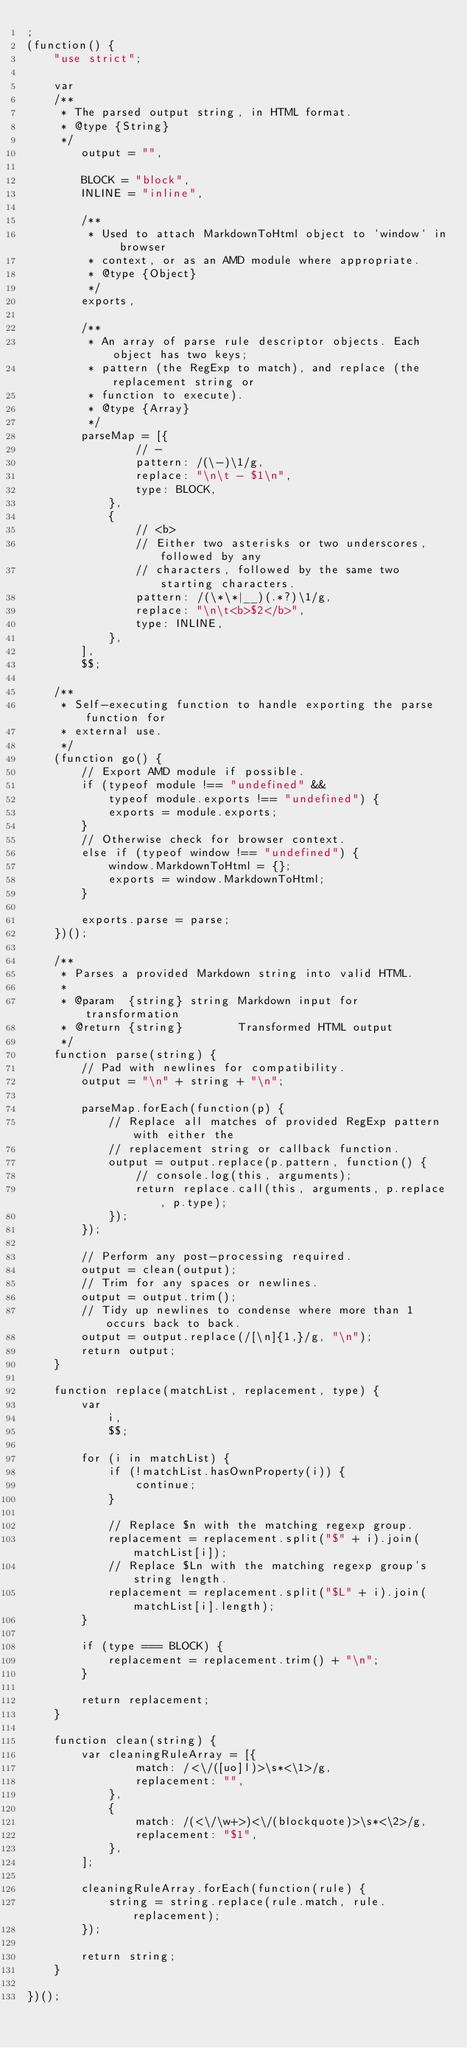Convert code to text. <code><loc_0><loc_0><loc_500><loc_500><_JavaScript_>;
(function() {
    "use strict";

    var
    /**
     * The parsed output string, in HTML format.
     * @type {String}
     */
        output = "",

        BLOCK = "block",
        INLINE = "inline",

        /**
         * Used to attach MarkdownToHtml object to `window` in browser
         * context, or as an AMD module where appropriate.
         * @type {Object}
         */
        exports,

        /**
         * An array of parse rule descriptor objects. Each object has two keys;
         * pattern (the RegExp to match), and replace (the replacement string or
         * function to execute).
         * @type {Array}
         */
        parseMap = [{
                // - 
                pattern: /(\-)\1/g,
                replace: "\n\t - $1\n",
                type: BLOCK,
            },
            {
                // <b>
                // Either two asterisks or two underscores, followed by any
                // characters, followed by the same two starting characters.
                pattern: /(\*\*|__)(.*?)\1/g,
                replace: "\n\t<b>$2</b>",
                type: INLINE,
            },
        ],
        $$;

    /**
     * Self-executing function to handle exporting the parse function for
     * external use.
     */
    (function go() {
        // Export AMD module if possible.
        if (typeof module !== "undefined" &&
            typeof module.exports !== "undefined") {
            exports = module.exports;
        }
        // Otherwise check for browser context.
        else if (typeof window !== "undefined") {
            window.MarkdownToHtml = {};
            exports = window.MarkdownToHtml;
        }

        exports.parse = parse;
    })();

    /**
     * Parses a provided Markdown string into valid HTML.
     *
     * @param  {string} string Markdown input for transformation
     * @return {string}        Transformed HTML output
     */
    function parse(string) {
        // Pad with newlines for compatibility.
        output = "\n" + string + "\n";

        parseMap.forEach(function(p) {
            // Replace all matches of provided RegExp pattern with either the
            // replacement string or callback function.
            output = output.replace(p.pattern, function() {
                // console.log(this, arguments);
                return replace.call(this, arguments, p.replace, p.type);
            });
        });

        // Perform any post-processing required.
        output = clean(output);
        // Trim for any spaces or newlines.
        output = output.trim();
        // Tidy up newlines to condense where more than 1 occurs back to back.
        output = output.replace(/[\n]{1,}/g, "\n");
        return output;
    }

    function replace(matchList, replacement, type) {
        var
            i,
            $$;

        for (i in matchList) {
            if (!matchList.hasOwnProperty(i)) {
                continue;
            }

            // Replace $n with the matching regexp group.
            replacement = replacement.split("$" + i).join(matchList[i]);
            // Replace $Ln with the matching regexp group's string length.
            replacement = replacement.split("$L" + i).join(matchList[i].length);
        }

        if (type === BLOCK) {
            replacement = replacement.trim() + "\n";
        }

        return replacement;
    }

    function clean(string) {
        var cleaningRuleArray = [{
                match: /<\/([uo]l)>\s*<\1>/g,
                replacement: "",
            },
            {
                match: /(<\/\w+>)<\/(blockquote)>\s*<\2>/g,
                replacement: "$1",
            },
        ];

        cleaningRuleArray.forEach(function(rule) {
            string = string.replace(rule.match, rule.replacement);
        });

        return string;
    }

})();</code> 